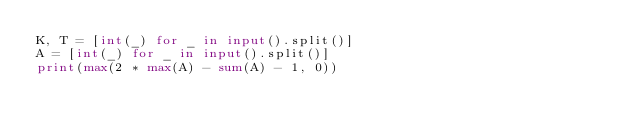Convert code to text. <code><loc_0><loc_0><loc_500><loc_500><_Python_>K, T = [int(_) for _ in input().split()]
A = [int(_) for _ in input().split()]
print(max(2 * max(A) - sum(A) - 1, 0))
</code> 